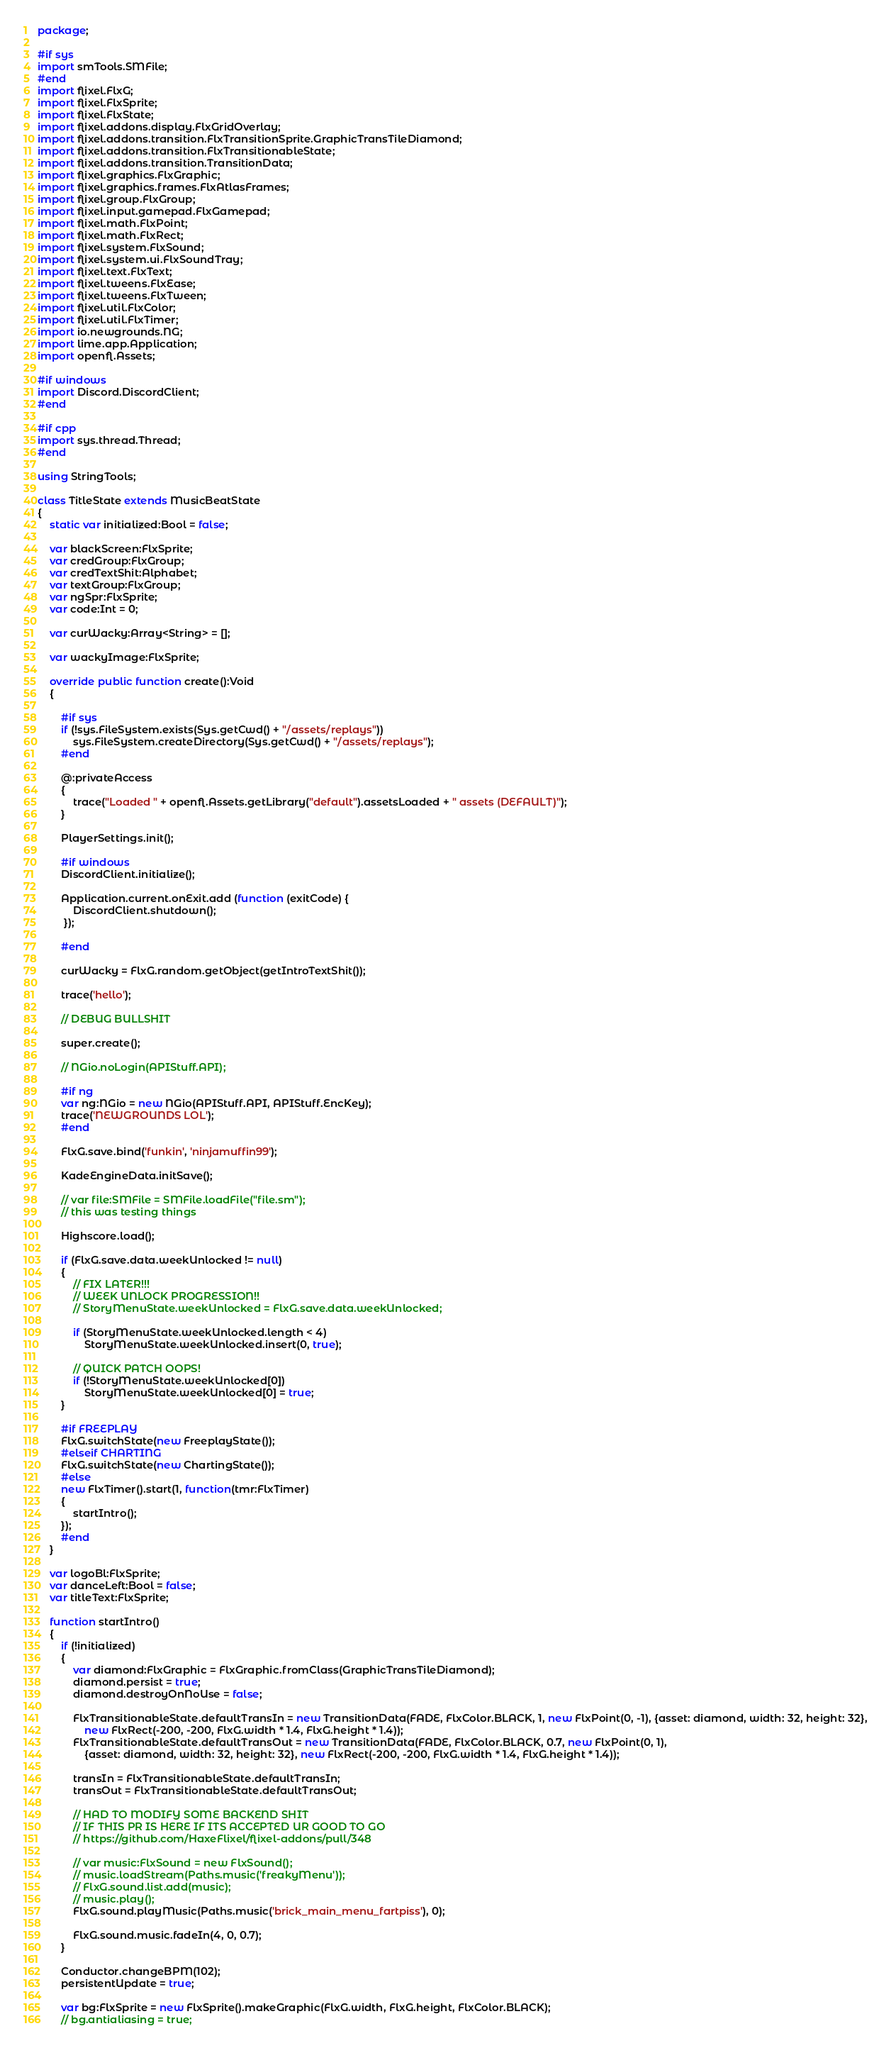<code> <loc_0><loc_0><loc_500><loc_500><_Haxe_>package;

#if sys
import smTools.SMFile;
#end
import flixel.FlxG;
import flixel.FlxSprite;
import flixel.FlxState;
import flixel.addons.display.FlxGridOverlay;
import flixel.addons.transition.FlxTransitionSprite.GraphicTransTileDiamond;
import flixel.addons.transition.FlxTransitionableState;
import flixel.addons.transition.TransitionData;
import flixel.graphics.FlxGraphic;
import flixel.graphics.frames.FlxAtlasFrames;
import flixel.group.FlxGroup;
import flixel.input.gamepad.FlxGamepad;
import flixel.math.FlxPoint;
import flixel.math.FlxRect;
import flixel.system.FlxSound;
import flixel.system.ui.FlxSoundTray;
import flixel.text.FlxText;
import flixel.tweens.FlxEase;
import flixel.tweens.FlxTween;
import flixel.util.FlxColor;
import flixel.util.FlxTimer;
import io.newgrounds.NG;
import lime.app.Application;
import openfl.Assets;

#if windows
import Discord.DiscordClient;
#end

#if cpp
import sys.thread.Thread;
#end

using StringTools;

class TitleState extends MusicBeatState
{
	static var initialized:Bool = false;

	var blackScreen:FlxSprite;
	var credGroup:FlxGroup;
	var credTextShit:Alphabet;
	var textGroup:FlxGroup;
	var ngSpr:FlxSprite;
	var code:Int = 0;

	var curWacky:Array<String> = [];

	var wackyImage:FlxSprite;

	override public function create():Void
	{
		
		#if sys
		if (!sys.FileSystem.exists(Sys.getCwd() + "/assets/replays"))
			sys.FileSystem.createDirectory(Sys.getCwd() + "/assets/replays");
		#end

		@:privateAccess
		{
			trace("Loaded " + openfl.Assets.getLibrary("default").assetsLoaded + " assets (DEFAULT)");
		}
		
		PlayerSettings.init();

		#if windows
		DiscordClient.initialize();

		Application.current.onExit.add (function (exitCode) {
			DiscordClient.shutdown();
		 });
		 
		#end

		curWacky = FlxG.random.getObject(getIntroTextShit());

		trace('hello');

		// DEBUG BULLSHIT

		super.create();

		// NGio.noLogin(APIStuff.API);

		#if ng
		var ng:NGio = new NGio(APIStuff.API, APIStuff.EncKey);
		trace('NEWGROUNDS LOL');
		#end

		FlxG.save.bind('funkin', 'ninjamuffin99');

		KadeEngineData.initSave();

		// var file:SMFile = SMFile.loadFile("file.sm");
		// this was testing things
		
		Highscore.load();

		if (FlxG.save.data.weekUnlocked != null)
		{
			// FIX LATER!!!
			// WEEK UNLOCK PROGRESSION!!
			// StoryMenuState.weekUnlocked = FlxG.save.data.weekUnlocked;

			if (StoryMenuState.weekUnlocked.length < 4)
				StoryMenuState.weekUnlocked.insert(0, true);

			// QUICK PATCH OOPS!
			if (!StoryMenuState.weekUnlocked[0])
				StoryMenuState.weekUnlocked[0] = true;
		}

		#if FREEPLAY
		FlxG.switchState(new FreeplayState());
		#elseif CHARTING
		FlxG.switchState(new ChartingState());
		#else
		new FlxTimer().start(1, function(tmr:FlxTimer)
		{
			startIntro();
		});
		#end
	}

	var logoBl:FlxSprite;
	var danceLeft:Bool = false;
	var titleText:FlxSprite;

	function startIntro()
	{
		if (!initialized)
		{
			var diamond:FlxGraphic = FlxGraphic.fromClass(GraphicTransTileDiamond);
			diamond.persist = true;
			diamond.destroyOnNoUse = false;

			FlxTransitionableState.defaultTransIn = new TransitionData(FADE, FlxColor.BLACK, 1, new FlxPoint(0, -1), {asset: diamond, width: 32, height: 32},
				new FlxRect(-200, -200, FlxG.width * 1.4, FlxG.height * 1.4));
			FlxTransitionableState.defaultTransOut = new TransitionData(FADE, FlxColor.BLACK, 0.7, new FlxPoint(0, 1),
				{asset: diamond, width: 32, height: 32}, new FlxRect(-200, -200, FlxG.width * 1.4, FlxG.height * 1.4));

			transIn = FlxTransitionableState.defaultTransIn;
			transOut = FlxTransitionableState.defaultTransOut;

			// HAD TO MODIFY SOME BACKEND SHIT
			// IF THIS PR IS HERE IF ITS ACCEPTED UR GOOD TO GO
			// https://github.com/HaxeFlixel/flixel-addons/pull/348

			// var music:FlxSound = new FlxSound();
			// music.loadStream(Paths.music('freakyMenu'));
			// FlxG.sound.list.add(music);
			// music.play();
			FlxG.sound.playMusic(Paths.music('brick_main_menu_fartpiss'), 0);

			FlxG.sound.music.fadeIn(4, 0, 0.7);
		}

		Conductor.changeBPM(102);
		persistentUpdate = true;

		var bg:FlxSprite = new FlxSprite().makeGraphic(FlxG.width, FlxG.height, FlxColor.BLACK);
		// bg.antialiasing = true;</code> 